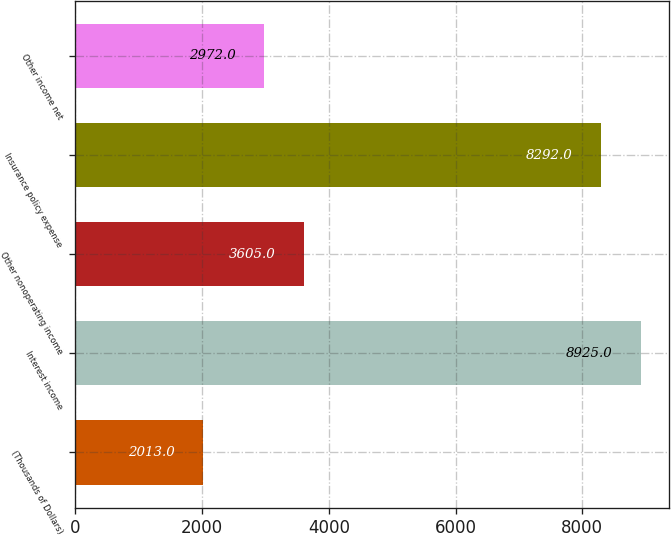<chart> <loc_0><loc_0><loc_500><loc_500><bar_chart><fcel>(Thousands of Dollars)<fcel>Interest income<fcel>Other nonoperating income<fcel>Insurance policy expense<fcel>Other income net<nl><fcel>2013<fcel>8925<fcel>3605<fcel>8292<fcel>2972<nl></chart> 